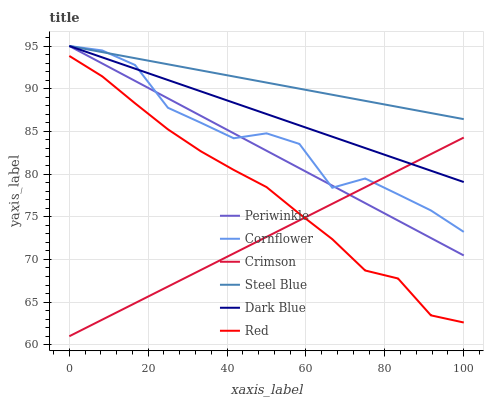Does Crimson have the minimum area under the curve?
Answer yes or no. Yes. Does Steel Blue have the maximum area under the curve?
Answer yes or no. Yes. Does Dark Blue have the minimum area under the curve?
Answer yes or no. No. Does Dark Blue have the maximum area under the curve?
Answer yes or no. No. Is Steel Blue the smoothest?
Answer yes or no. Yes. Is Cornflower the roughest?
Answer yes or no. Yes. Is Dark Blue the smoothest?
Answer yes or no. No. Is Dark Blue the roughest?
Answer yes or no. No. Does Crimson have the lowest value?
Answer yes or no. Yes. Does Dark Blue have the lowest value?
Answer yes or no. No. Does Periwinkle have the highest value?
Answer yes or no. Yes. Does Crimson have the highest value?
Answer yes or no. No. Is Red less than Dark Blue?
Answer yes or no. Yes. Is Cornflower greater than Red?
Answer yes or no. Yes. Does Periwinkle intersect Dark Blue?
Answer yes or no. Yes. Is Periwinkle less than Dark Blue?
Answer yes or no. No. Is Periwinkle greater than Dark Blue?
Answer yes or no. No. Does Red intersect Dark Blue?
Answer yes or no. No. 